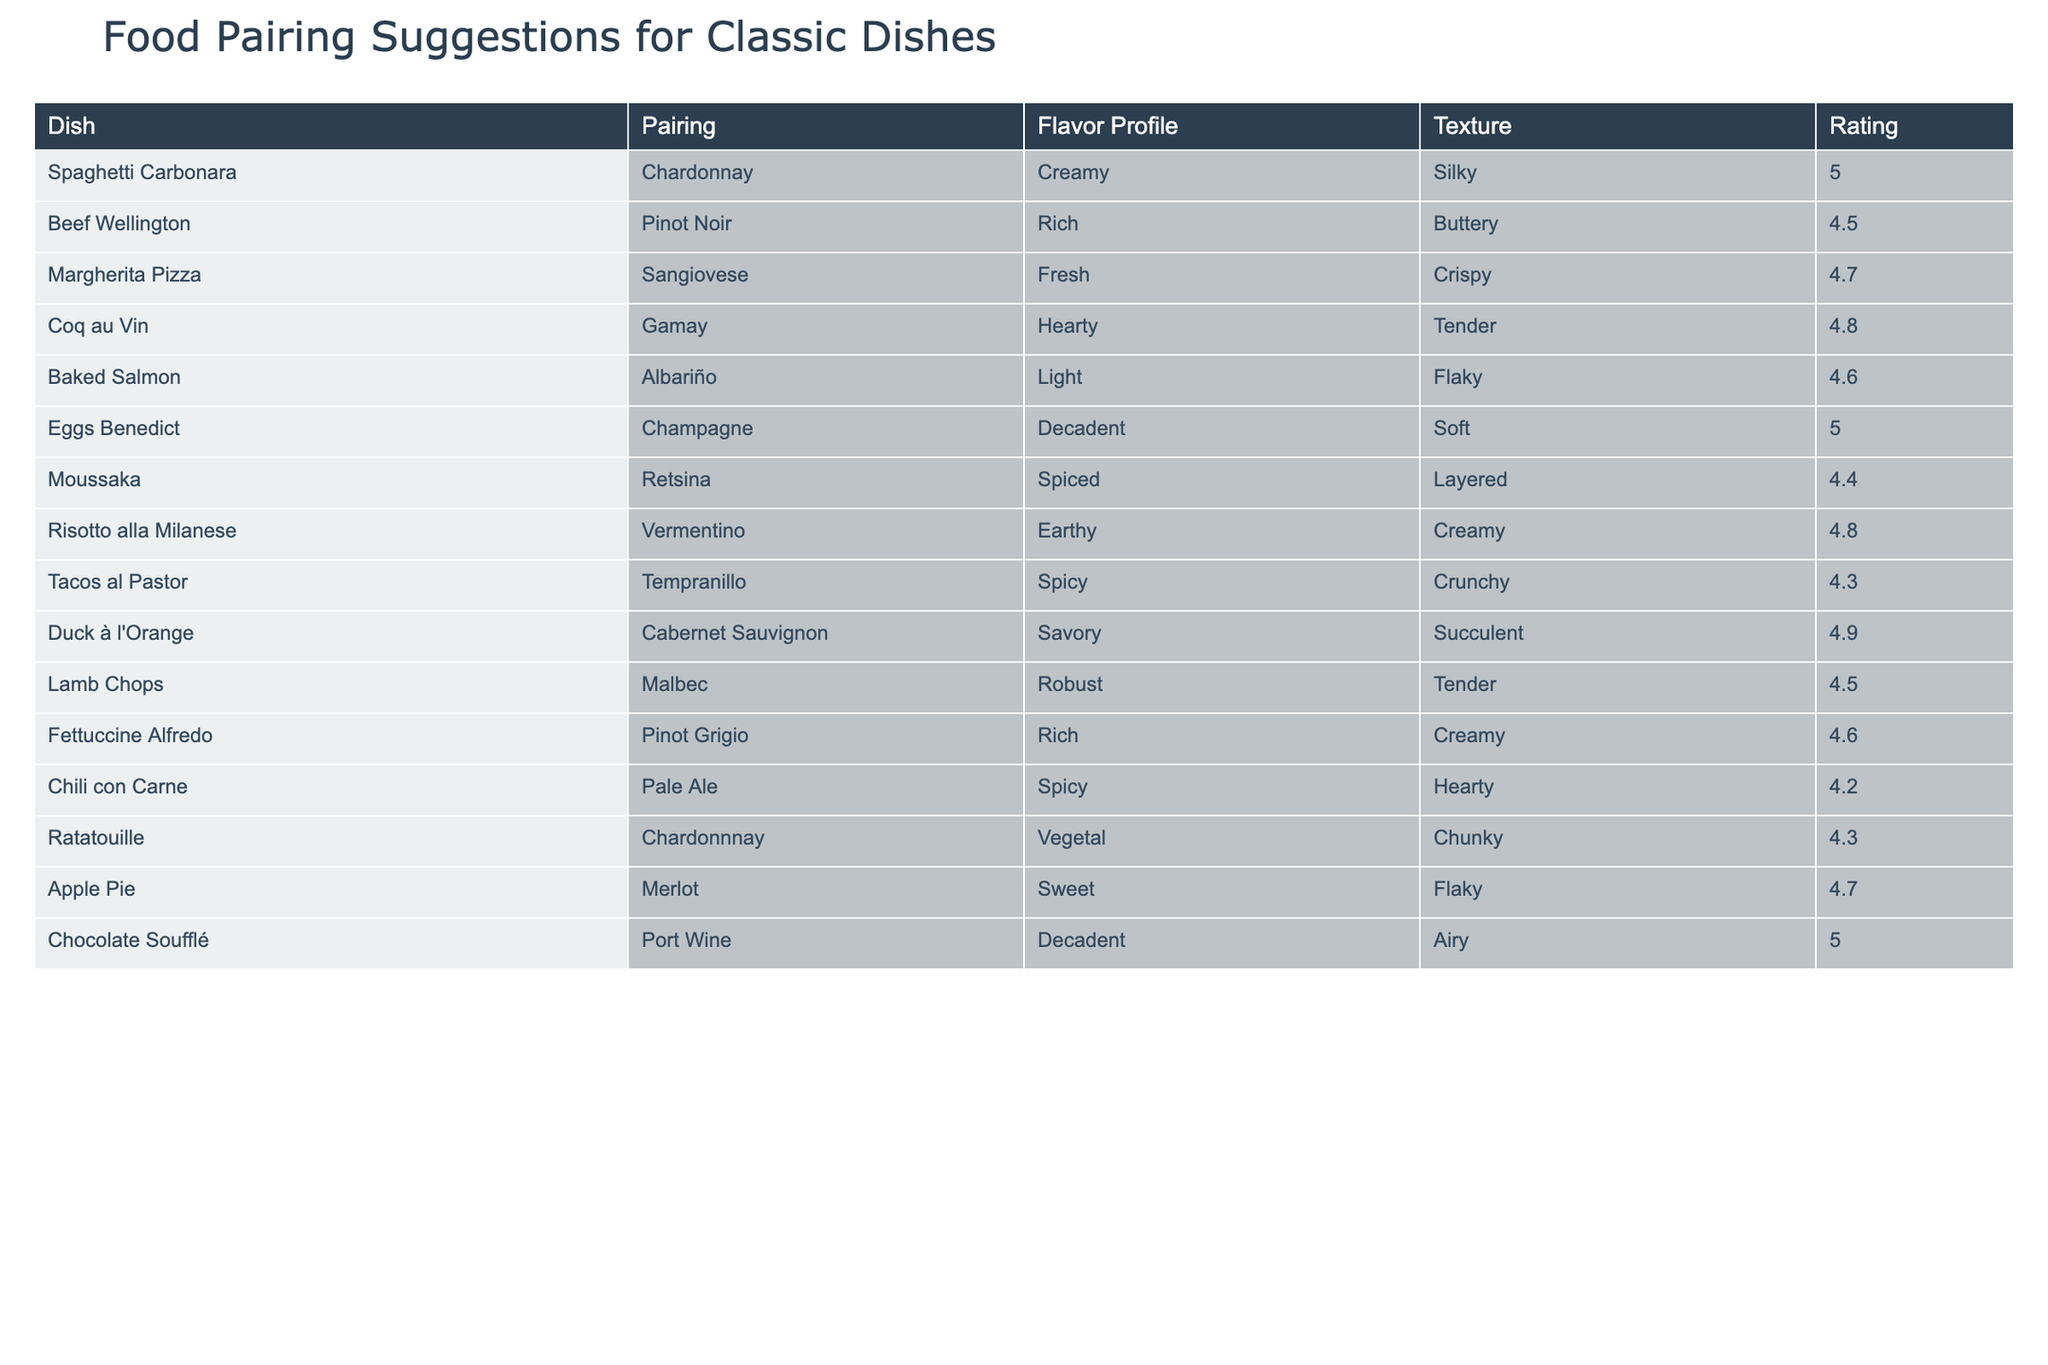What is the pairing for Duck à l'Orange? The table lists Duck à l'Orange paired with Cabernet Sauvignon. This can be found in the second column corresponding to the row for Duck à l'Orange.
Answer: Cabernet Sauvignon Which dish has the highest rating? By inspecting the last column, we find that Chocolate Soufflé has the highest rating of 5. This is confirmed by scanning all the ratings given for each dish and identifying the maximum value.
Answer: Chocolate Soufflé How many dishes have a rating above 4.5? To find this, we can count the number of rows where the rating column has values greater than 4.5. Upon reviewing the table, 6 dishes meet this criterion: Spaghetti Carbonara, Eggs Benedict, Coq au Vin, Duck à l'Orange, Chocolate Soufflé, and Risotto alla Milanese.
Answer: 6 What is the average rating of the dishes that are paired with red wines? The red wines in the table are Pinot Noir, Sangiovese, Gamay, Cabernet Sauvignon, Malbec, and Tempranillo. The corresponding ratings for these dishes are 4.5, 4.7, 4.8, 4.9, 4.5, and 4.3. The sum of these ratings is 4.5 + 4.7 + 4.8 + 4.9 + 4.5 + 4.3 = 27.7, and there are 6 dishes. Dividing 27.7 by 6 gives an average rating of approximately 4.62.
Answer: 4.62 Is there a dish that is paired with a white wine and has a rating of 4.8 or higher? Yes, examining the table shows that both Eggs Benedict (paired with Champagne) and Risotto alla Milanese (paired with Vermentino) have ratings of 5 and 4.8 respectively, which is above the threshold. Therefore, the answer is yes.
Answer: Yes Which dish has a spiced flavor profile, and what is its pairing? The table indicates that Moussaka has a spiced flavor profile, and it is paired with Retsina. This is determined by locating Moussaka in the table and checking the corresponding columns for flavor profile and pairing.
Answer: Retsina What is the total number of dishes listed in the table? There are 12 rows of data in the table, each representing a distinct dish. The simplicity of the question allows for an immediate count.
Answer: 12 Which wine is paired with the light-textured dish? The only light-textured dish on the list is Baked Salmon, which is paired with Albariño according to the table. This can be verified by locating the Baked Salmon row and reading across to the pairing column.
Answer: Albariño 